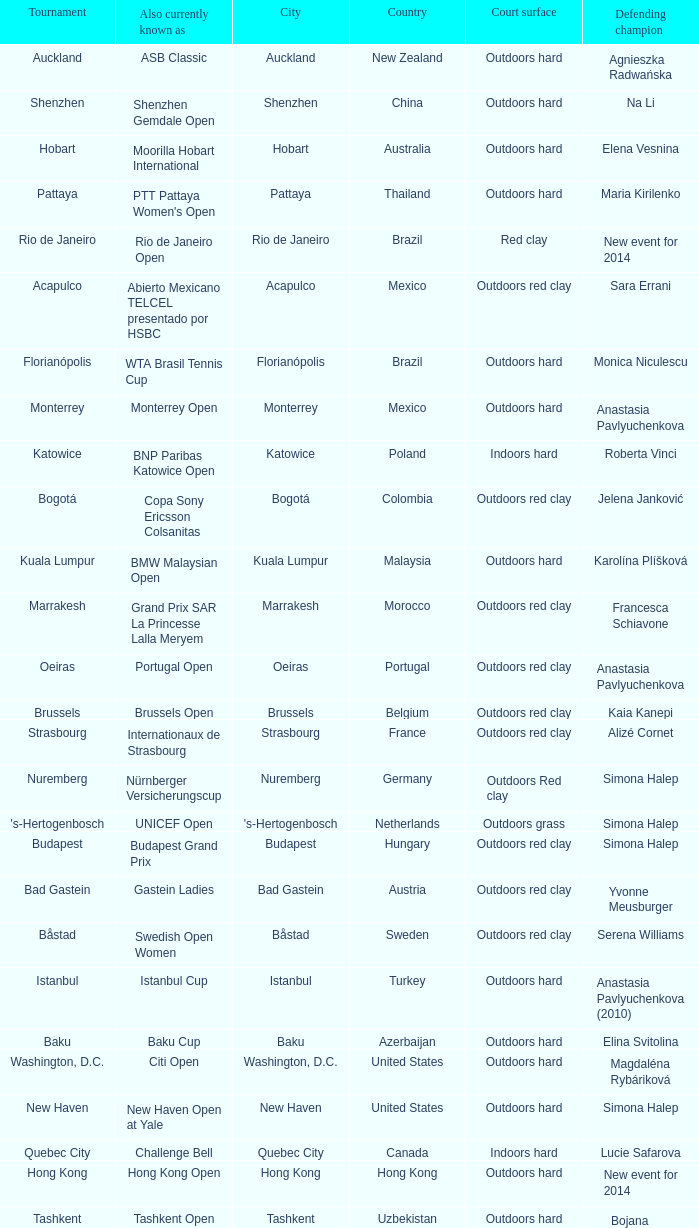How many defending champs from thailand? 1.0. 